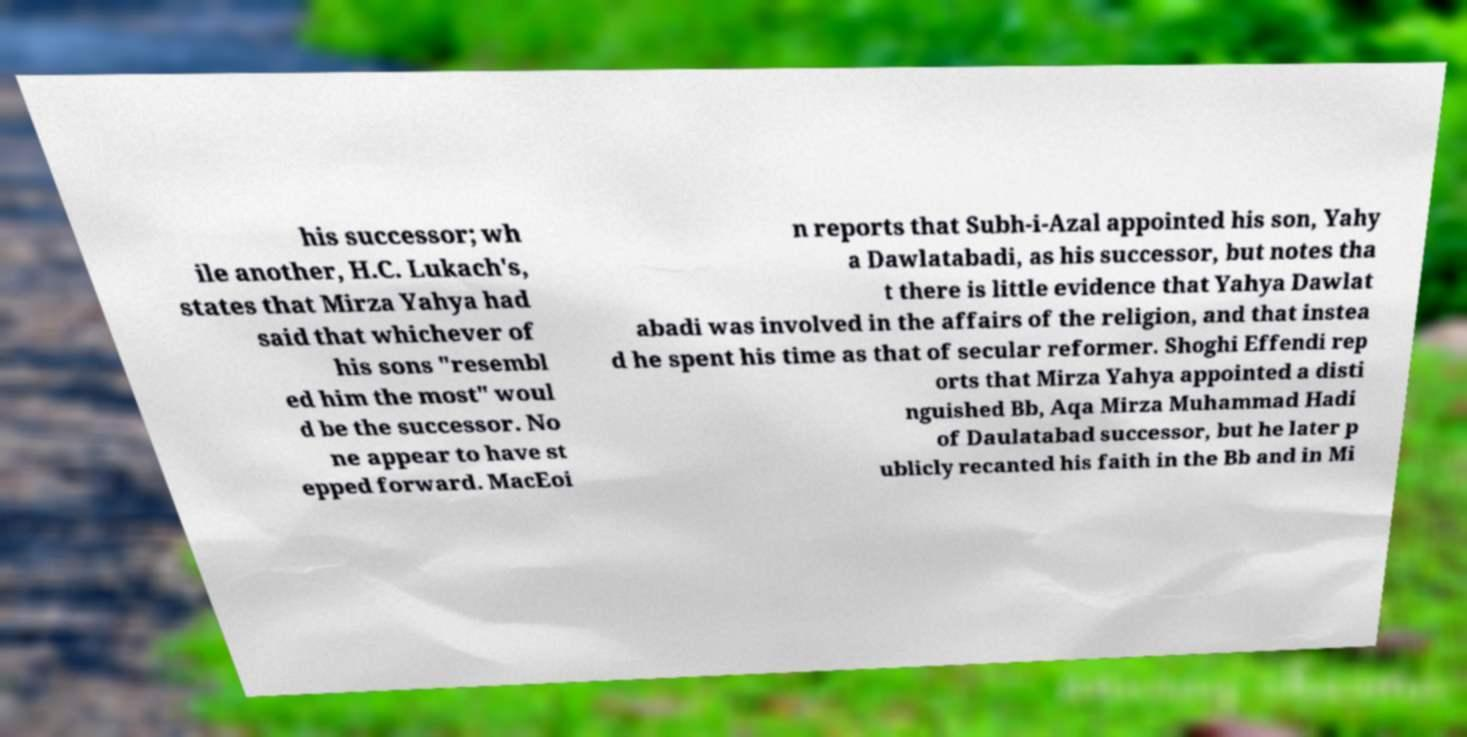Could you assist in decoding the text presented in this image and type it out clearly? his successor; wh ile another, H.C. Lukach's, states that Mirza Yahya had said that whichever of his sons "resembl ed him the most" woul d be the successor. No ne appear to have st epped forward. MacEoi n reports that Subh-i-Azal appointed his son, Yahy a Dawlatabadi, as his successor, but notes tha t there is little evidence that Yahya Dawlat abadi was involved in the affairs of the religion, and that instea d he spent his time as that of secular reformer. Shoghi Effendi rep orts that Mirza Yahya appointed a disti nguished Bb, Aqa Mirza Muhammad Hadi of Daulatabad successor, but he later p ublicly recanted his faith in the Bb and in Mi 